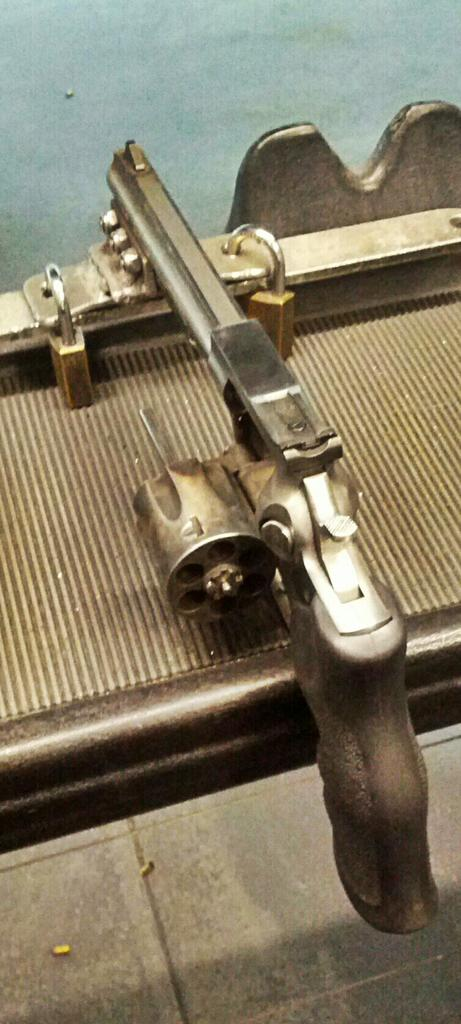What is the main object in the image? There is a gun in the image. Where is the gun placed? The gun is placed on a metal object. What else can be seen in the image besides the gun? There are locks in the image. What type of rhythm can be heard coming from the hall in the image? There is no hall or any sound mentioned in the image, so it's not possible to determine what rhythm might be heard. 